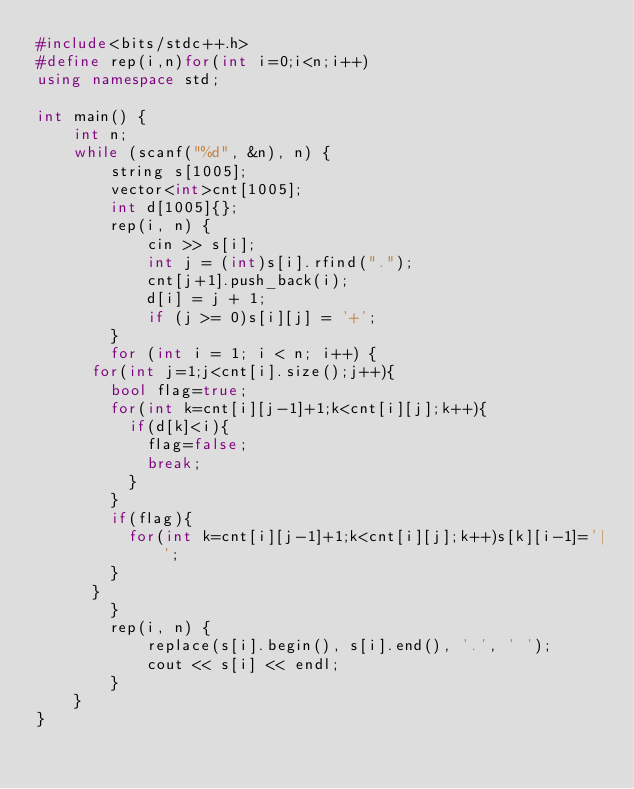<code> <loc_0><loc_0><loc_500><loc_500><_C++_>#include<bits/stdc++.h>
#define rep(i,n)for(int i=0;i<n;i++)
using namespace std;
 
int main() {
    int n;
    while (scanf("%d", &n), n) {
        string s[1005];
        vector<int>cnt[1005];
        int d[1005]{};
        rep(i, n) {
            cin >> s[i];
            int j = (int)s[i].rfind(".");
            cnt[j+1].push_back(i);
            d[i] = j + 1;
            if (j >= 0)s[i][j] = '+';
        }
        for (int i = 1; i < n; i++) {
			for(int j=1;j<cnt[i].size();j++){
				bool flag=true;
				for(int k=cnt[i][j-1]+1;k<cnt[i][j];k++){
					if(d[k]<i){
						flag=false;
						break;
					}
				}
				if(flag){
					for(int k=cnt[i][j-1]+1;k<cnt[i][j];k++)s[k][i-1]='|';
				}
			}
        }
        rep(i, n) {
            replace(s[i].begin(), s[i].end(), '.', ' ');
            cout << s[i] << endl;
        }
    }
}</code> 